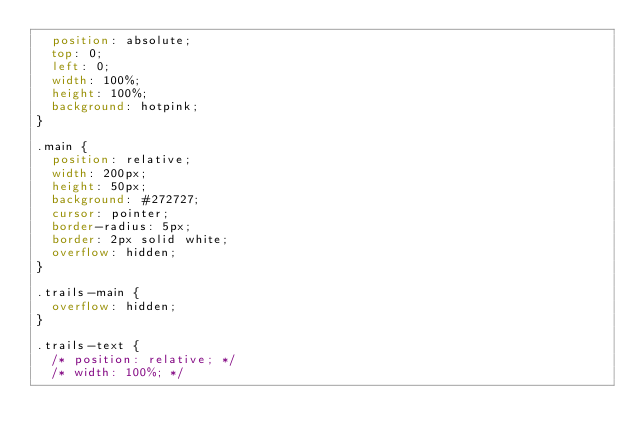<code> <loc_0><loc_0><loc_500><loc_500><_CSS_>  position: absolute;
  top: 0;
  left: 0;
  width: 100%;
  height: 100%;
  background: hotpink;
}

.main {
  position: relative;
  width: 200px;
  height: 50px;
  background: #272727;
  cursor: pointer;
  border-radius: 5px;
  border: 2px solid white;
  overflow: hidden;
}

.trails-main {
  overflow: hidden;
}

.trails-text {
  /* position: relative; */
  /* width: 100%; */</code> 